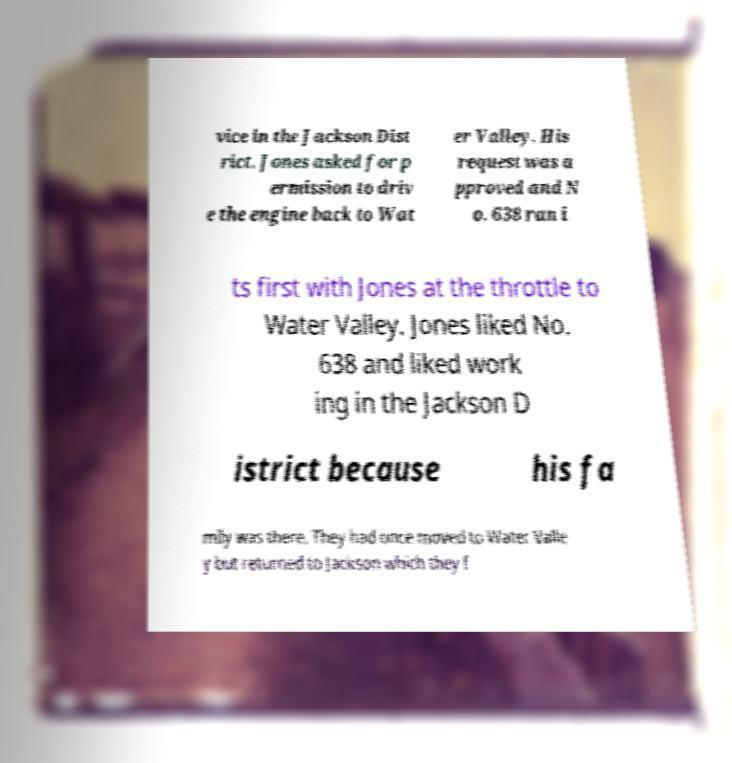Can you accurately transcribe the text from the provided image for me? vice in the Jackson Dist rict. Jones asked for p ermission to driv e the engine back to Wat er Valley. His request was a pproved and N o. 638 ran i ts first with Jones at the throttle to Water Valley. Jones liked No. 638 and liked work ing in the Jackson D istrict because his fa mily was there. They had once moved to Water Valle y but returned to Jackson which they f 